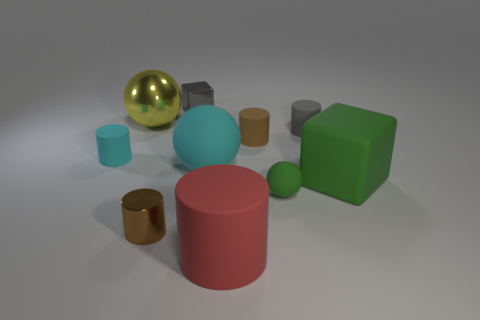Subtract all gray cylinders. How many cylinders are left? 4 Subtract all small brown matte cylinders. How many cylinders are left? 4 Subtract all green cylinders. Subtract all gray spheres. How many cylinders are left? 5 Subtract all blocks. How many objects are left? 8 Subtract 0 yellow cylinders. How many objects are left? 10 Subtract all green balls. Subtract all small matte cylinders. How many objects are left? 6 Add 3 large yellow balls. How many large yellow balls are left? 4 Add 6 red metal cubes. How many red metal cubes exist? 6 